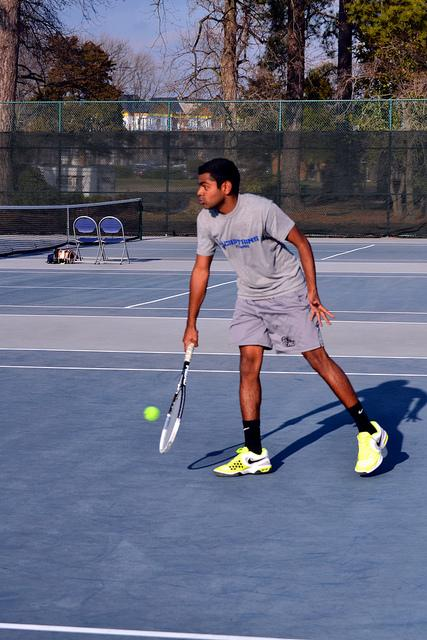Which object is in motion? ball 